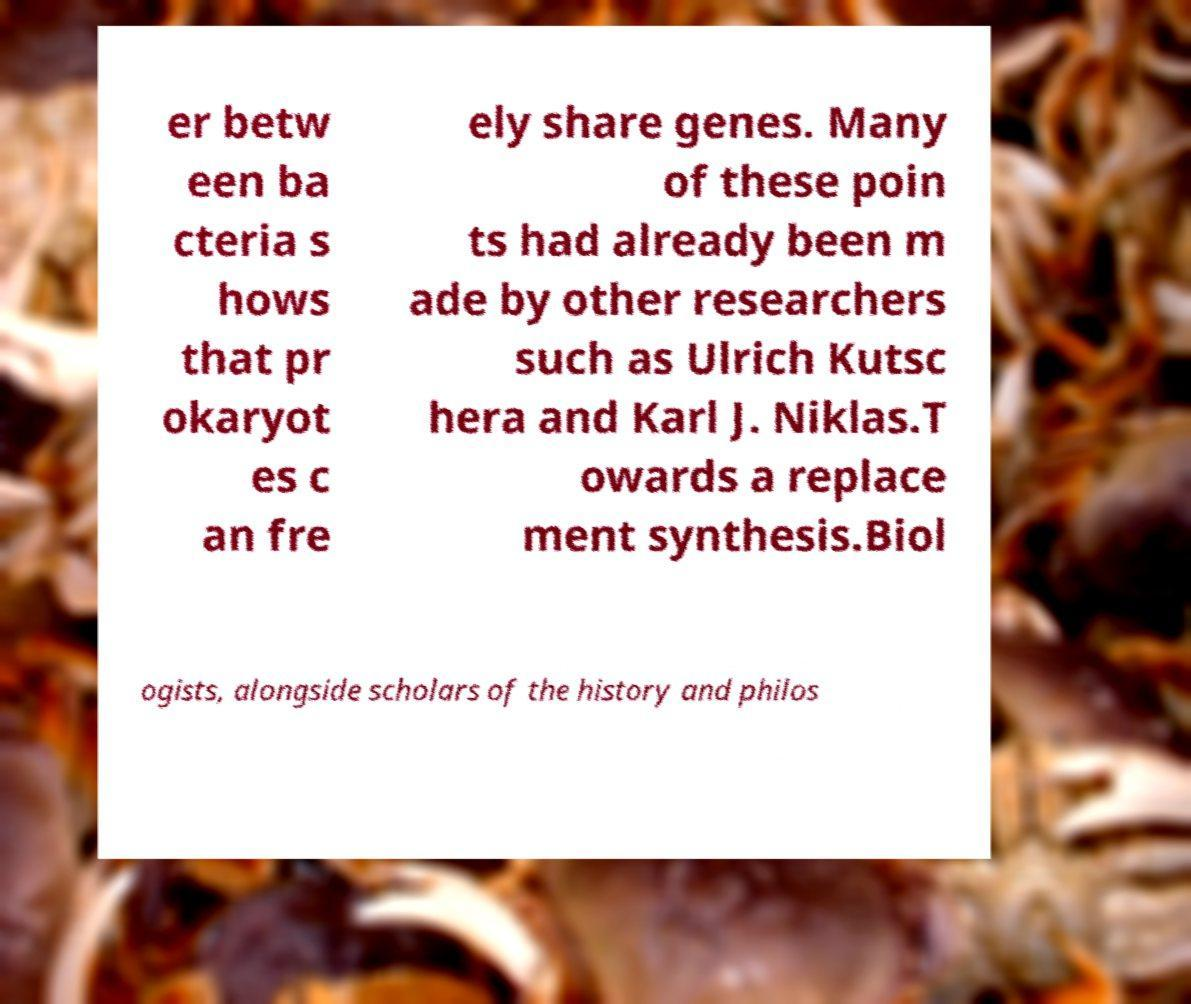There's text embedded in this image that I need extracted. Can you transcribe it verbatim? er betw een ba cteria s hows that pr okaryot es c an fre ely share genes. Many of these poin ts had already been m ade by other researchers such as Ulrich Kutsc hera and Karl J. Niklas.T owards a replace ment synthesis.Biol ogists, alongside scholars of the history and philos 